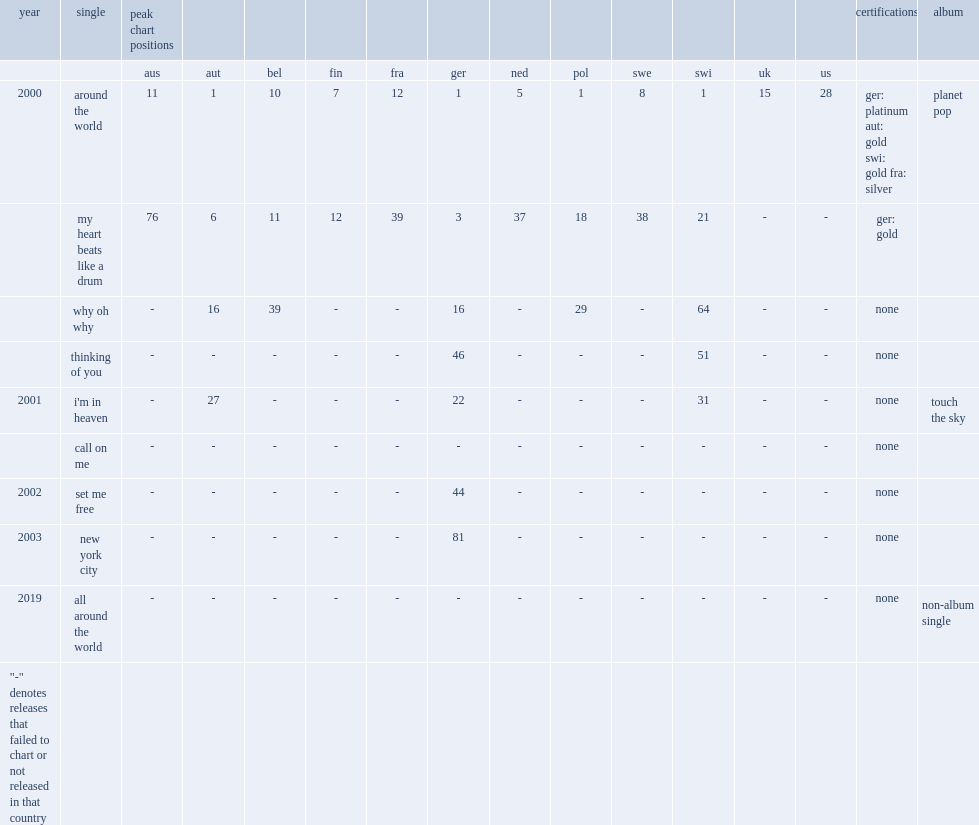When did "new york city" release? 2003.0. 